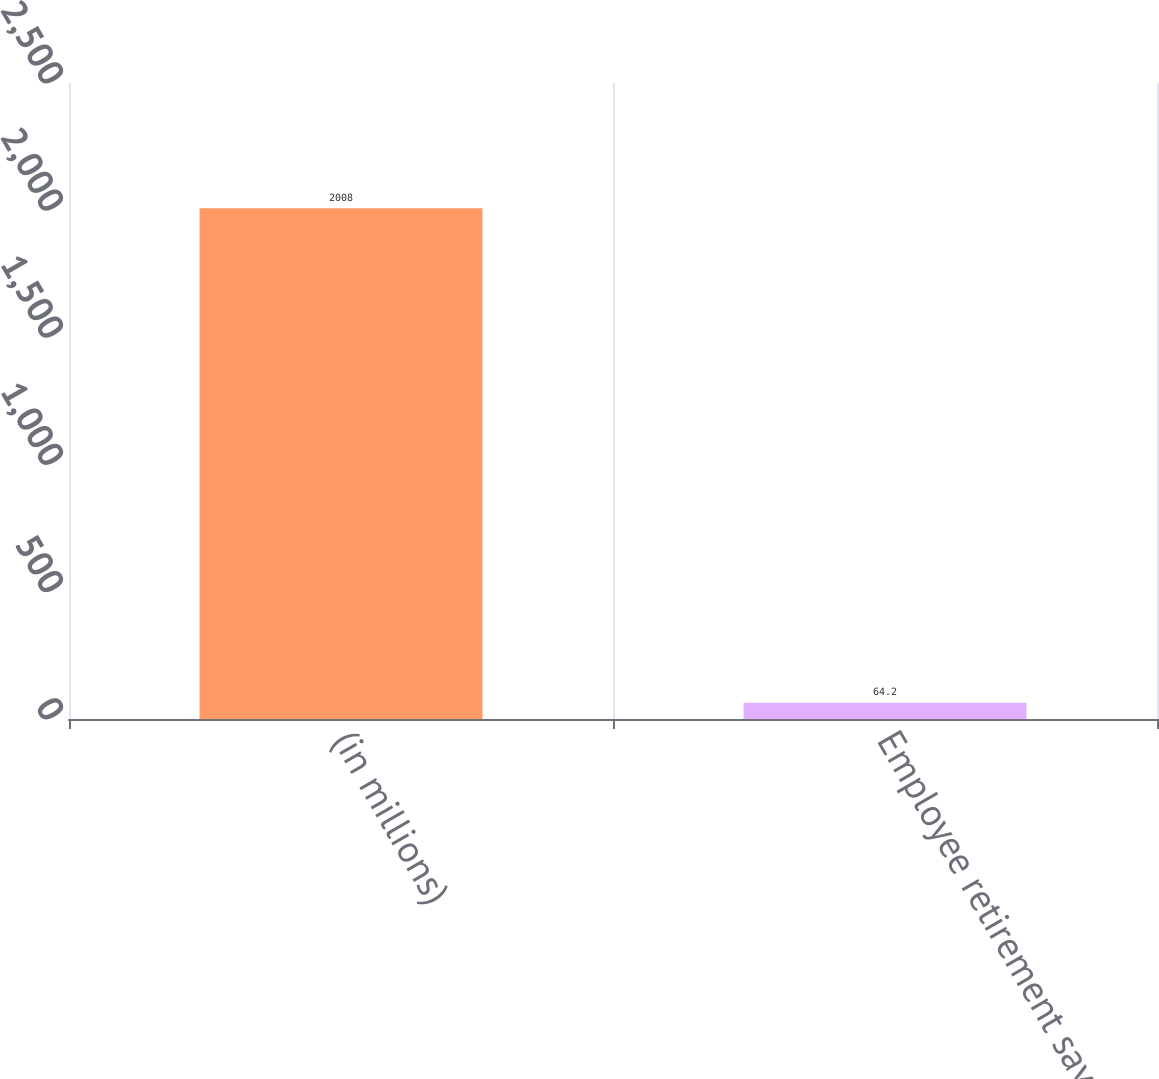Convert chart to OTSL. <chart><loc_0><loc_0><loc_500><loc_500><bar_chart><fcel>(in millions)<fcel>Employee retirement savings<nl><fcel>2008<fcel>64.2<nl></chart> 